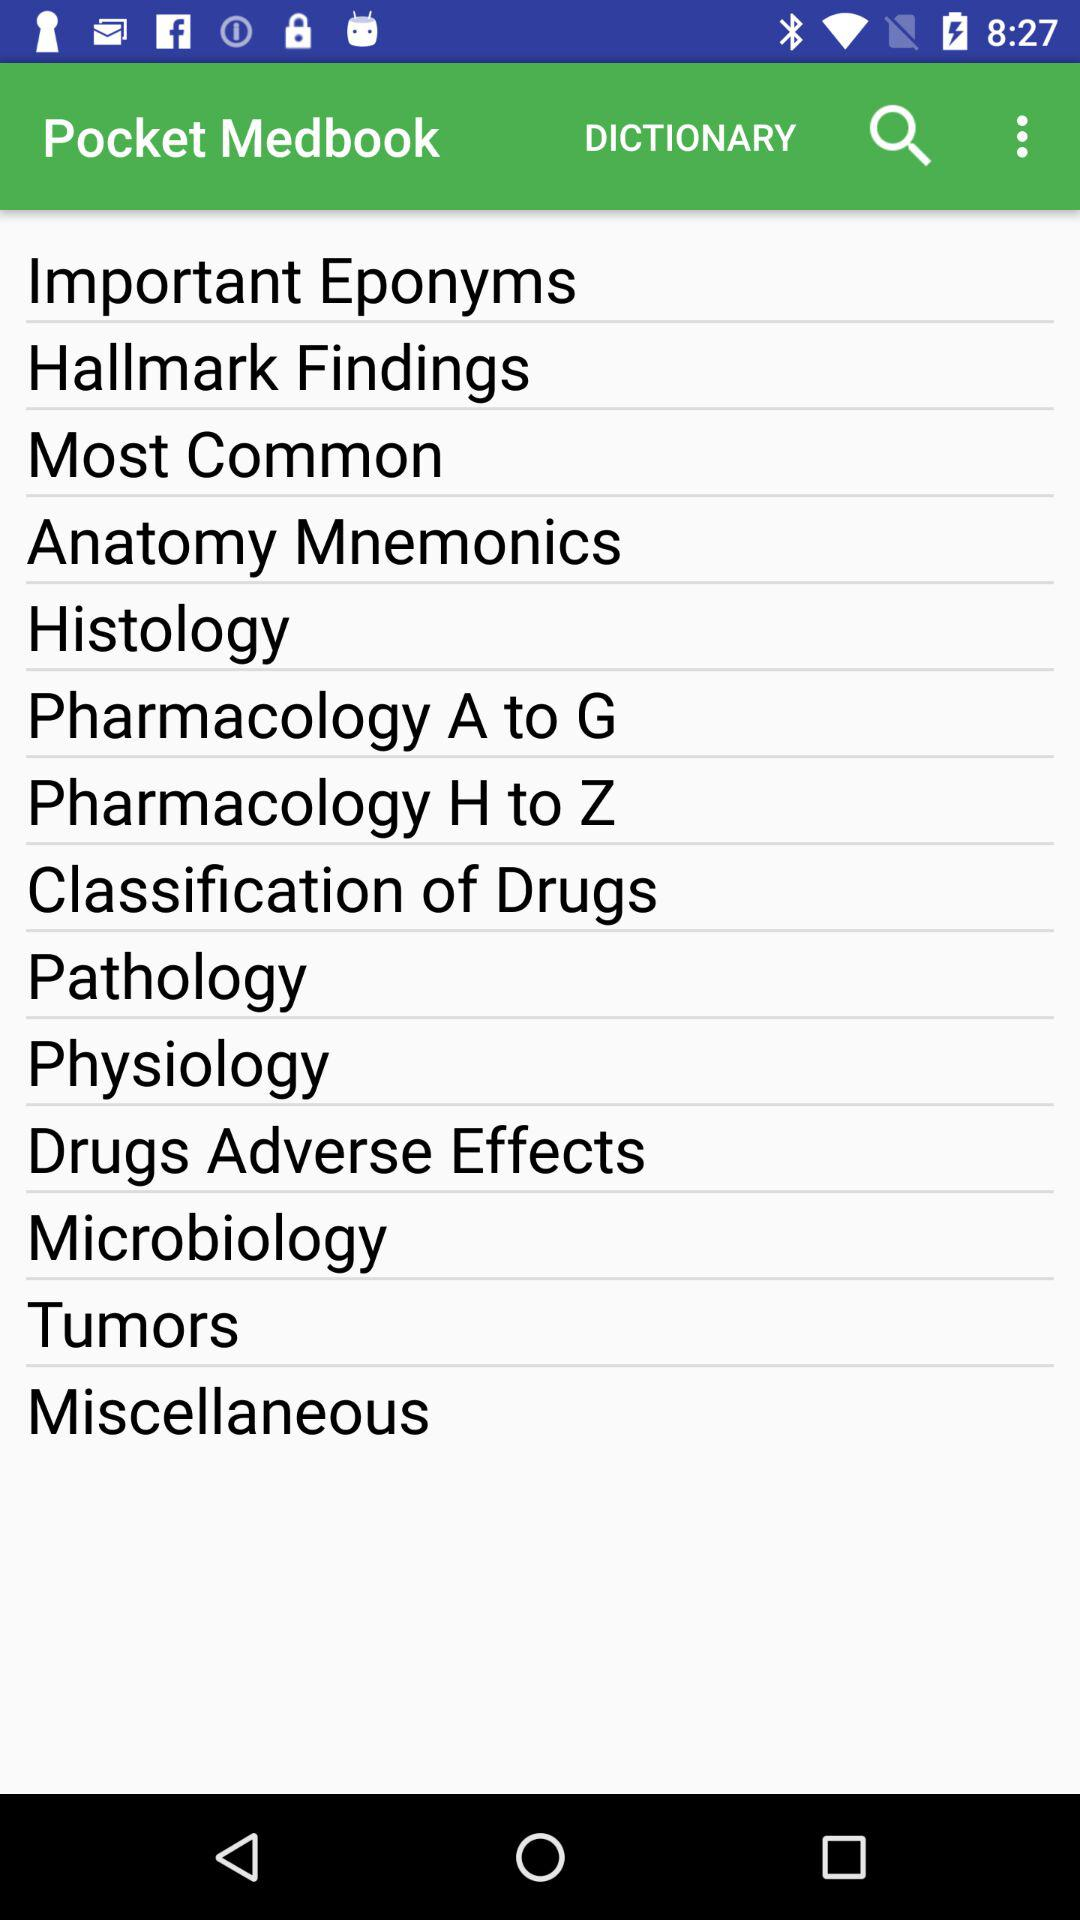What is the name of the application? The name of the application is "Pocket Medbook". 